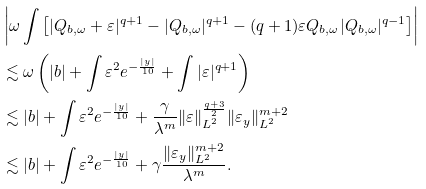Convert formula to latex. <formula><loc_0><loc_0><loc_500><loc_500>& \left | \omega \int \left [ | Q _ { b , \omega } + \varepsilon | ^ { q + 1 } - | Q _ { b , \omega } | ^ { q + 1 } - ( q + 1 ) \varepsilon Q _ { b , \omega } | Q _ { b , \omega } | ^ { q - 1 } \right ] \right | \\ & \lesssim \omega \left ( | b | + \int \varepsilon ^ { 2 } e ^ { - \frac { | y | } { 1 0 } } + \int | \varepsilon | ^ { q + 1 } \right ) \\ & \lesssim | b | + \int \varepsilon ^ { 2 } e ^ { - \frac { | y | } { 1 0 } } + \frac { \gamma } { \lambda ^ { m } } \| \varepsilon \| _ { L ^ { 2 } } ^ { \frac { q + 3 } { 2 } } \| \varepsilon _ { y } \| _ { L ^ { 2 } } ^ { m + 2 } \\ & \lesssim | b | + \int \varepsilon ^ { 2 } e ^ { - \frac { | y | } { 1 0 } } + \gamma \frac { \| \varepsilon _ { y } \| _ { L ^ { 2 } } ^ { m + 2 } } { \lambda ^ { m } } .</formula> 